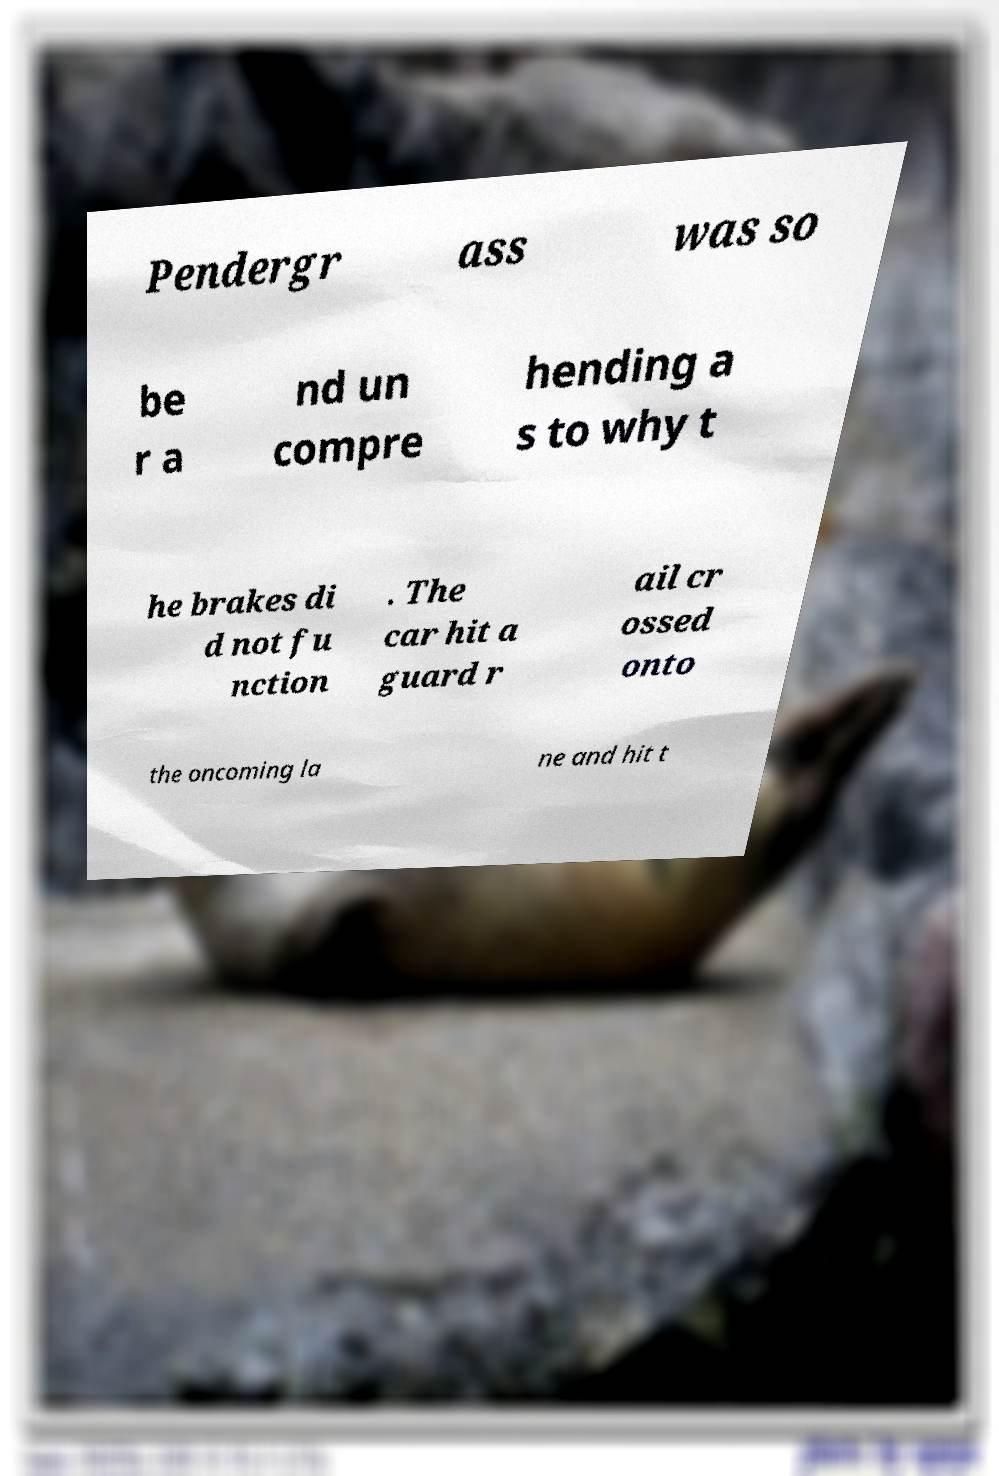For documentation purposes, I need the text within this image transcribed. Could you provide that? Pendergr ass was so be r a nd un compre hending a s to why t he brakes di d not fu nction . The car hit a guard r ail cr ossed onto the oncoming la ne and hit t 